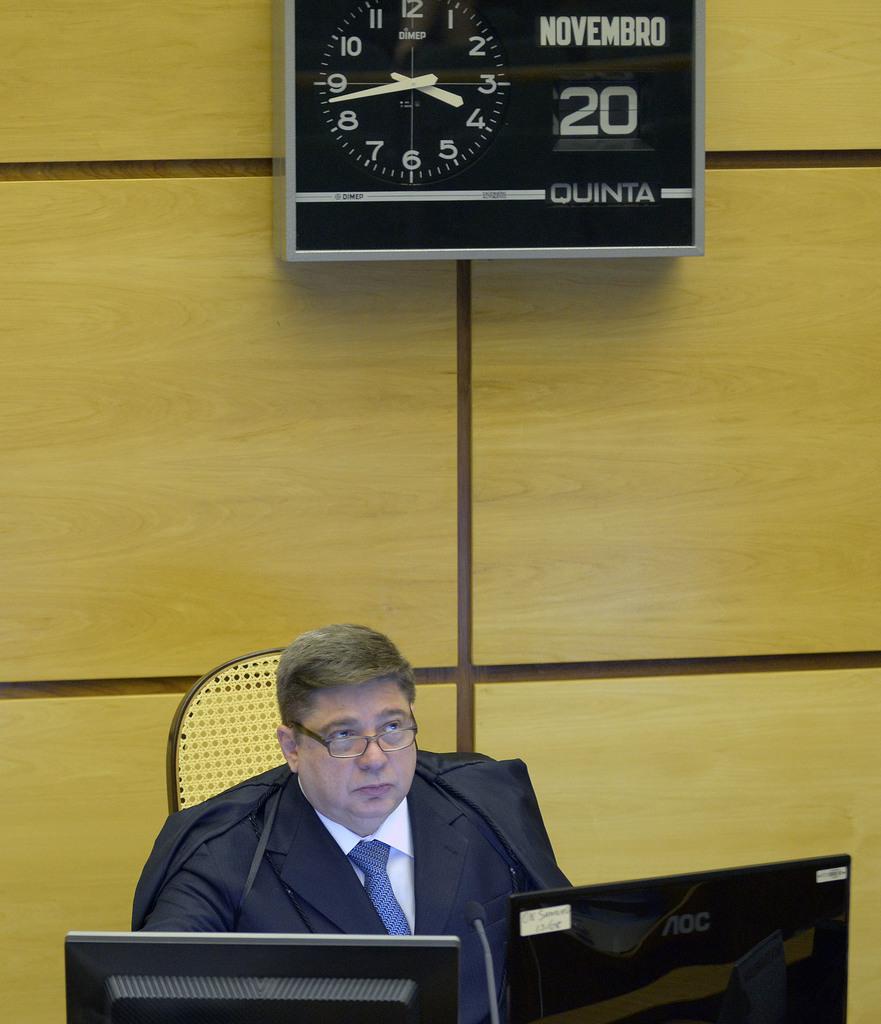What day of november is it?
Provide a short and direct response. 20. 